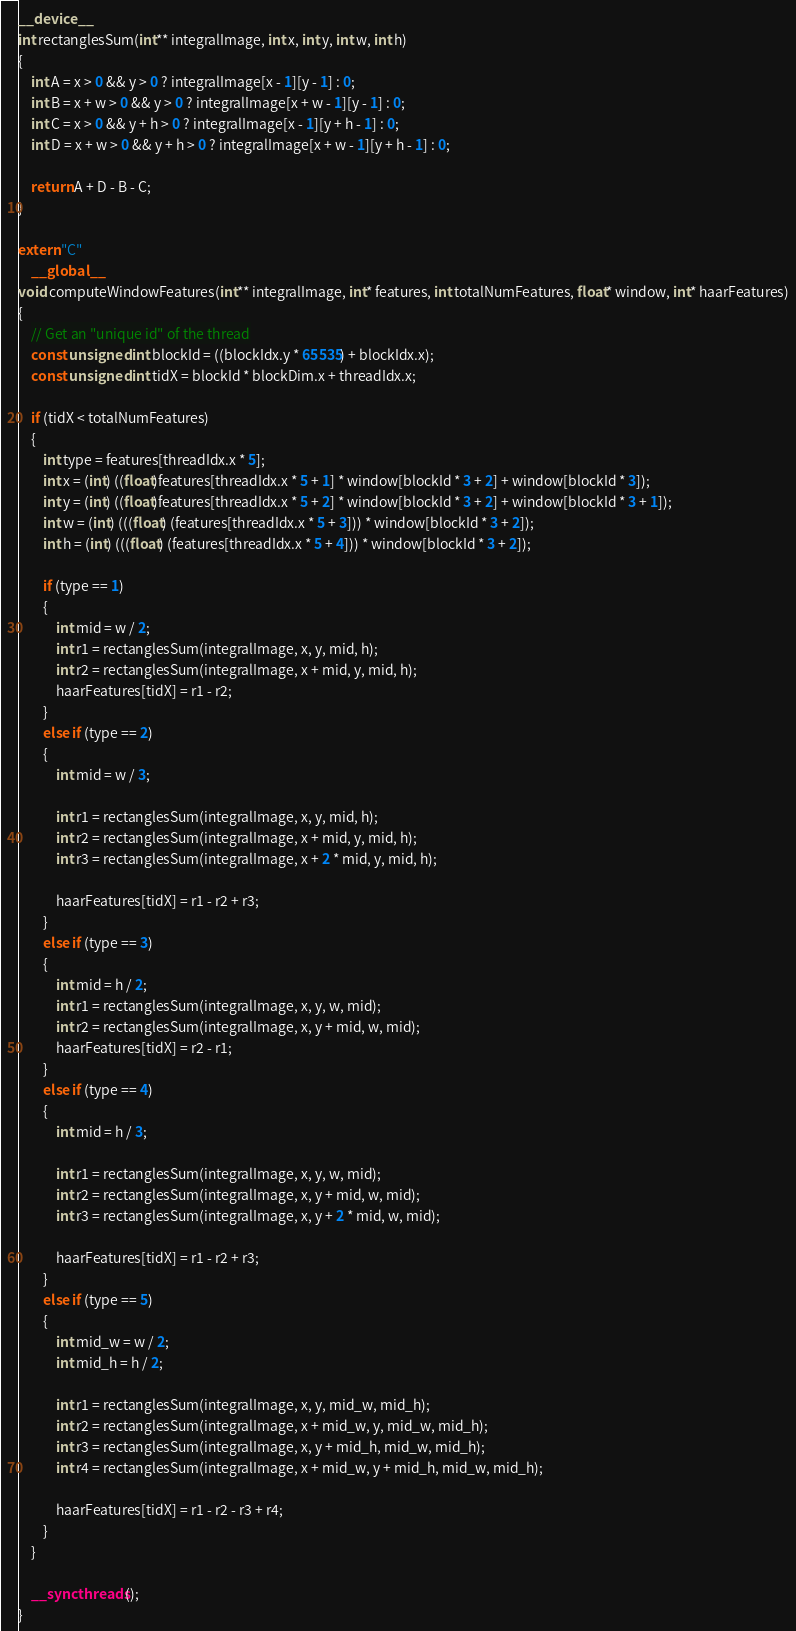<code> <loc_0><loc_0><loc_500><loc_500><_Cuda_>__device__
int rectanglesSum(int** integralImage, int x, int y, int w, int h)
{
	int A = x > 0 && y > 0 ? integralImage[x - 1][y - 1] : 0;
	int B = x + w > 0 && y > 0 ? integralImage[x + w - 1][y - 1] : 0;
	int C = x > 0 && y + h > 0 ? integralImage[x - 1][y + h - 1] : 0;
	int D = x + w > 0 && y + h > 0 ? integralImage[x + w - 1][y + h - 1] : 0;

	return A + D - B - C;
}

extern "C"
	__global__
void computeWindowFeatures(int** integralImage, int* features, int totalNumFeatures, float* window, int* haarFeatures)
{
	// Get an "unique id" of the thread
	const unsigned int blockId = ((blockIdx.y * 65535) + blockIdx.x);
	const unsigned int tidX = blockId * blockDim.x + threadIdx.x;

	if (tidX < totalNumFeatures)
	{
		int type = features[threadIdx.x * 5];
        int x = (int) ((float)features[threadIdx.x * 5 + 1] * window[blockId * 3 + 2] + window[blockId * 3]);
        int y = (int) ((float)features[threadIdx.x * 5 + 2] * window[blockId * 3 + 2] + window[blockId * 3 + 1]);
		int w = (int) (((float) (features[threadIdx.x * 5 + 3])) * window[blockId * 3 + 2]);
		int h = (int) (((float) (features[threadIdx.x * 5 + 4])) * window[blockId * 3 + 2]);

		if (type == 1)
		{
			int mid = w / 2;
			int r1 = rectanglesSum(integralImage, x, y, mid, h);
			int r2 = rectanglesSum(integralImage, x + mid, y, mid, h);
			haarFeatures[tidX] = r1 - r2;
		}
		else if (type == 2)
		{
			int mid = w / 3;

			int r1 = rectanglesSum(integralImage, x, y, mid, h);
			int r2 = rectanglesSum(integralImage, x + mid, y, mid, h);
			int r3 = rectanglesSum(integralImage, x + 2 * mid, y, mid, h);

			haarFeatures[tidX] = r1 - r2 + r3;
		}
		else if (type == 3)
		{
			int mid = h / 2;
			int r1 = rectanglesSum(integralImage, x, y, w, mid);
			int r2 = rectanglesSum(integralImage, x, y + mid, w, mid);
			haarFeatures[tidX] = r2 - r1;
		}
		else if (type == 4)
		{
			int mid = h / 3;

			int r1 = rectanglesSum(integralImage, x, y, w, mid);
			int r2 = rectanglesSum(integralImage, x, y + mid, w, mid);
			int r3 = rectanglesSum(integralImage, x, y + 2 * mid, w, mid);

			haarFeatures[tidX] = r1 - r2 + r3;
		}
		else if (type == 5)
		{
			int mid_w = w / 2;
			int mid_h = h / 2;

			int r1 = rectanglesSum(integralImage, x, y, mid_w, mid_h);
			int r2 = rectanglesSum(integralImage, x + mid_w, y, mid_w, mid_h);
			int r3 = rectanglesSum(integralImage, x, y + mid_h, mid_w, mid_h);
			int r4 = rectanglesSum(integralImage, x + mid_w, y + mid_h, mid_w, mid_h);

			haarFeatures[tidX] = r1 - r2 - r3 + r4;
		}
	}

	__syncthreads();
}
</code> 